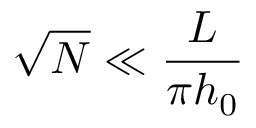<formula> <loc_0><loc_0><loc_500><loc_500>\sqrt { N } \ll \frac { L } { \pi h _ { 0 } }</formula> 